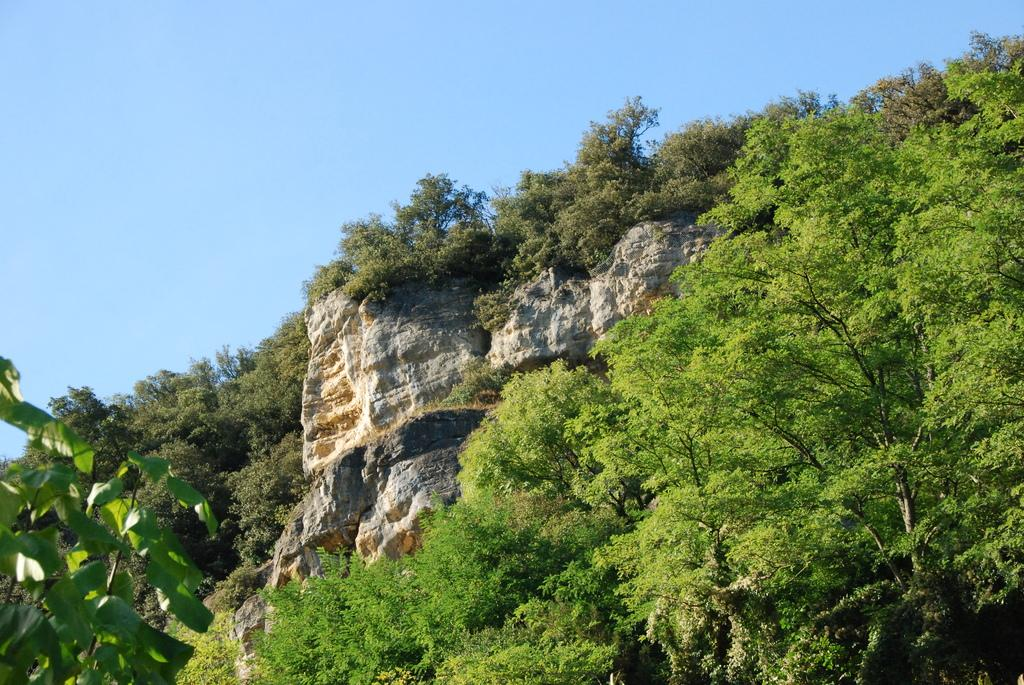What type of vegetation can be seen in the image? There are trees in the image. What geographical feature is present in the image? There is a hill in the image. What can be seen in the background of the image? The sky is visible in the background of the image. What type of cake is being served on the wall in the image? There is no cake or wall present in the image; it features trees and a hill with the sky visible in the background. 